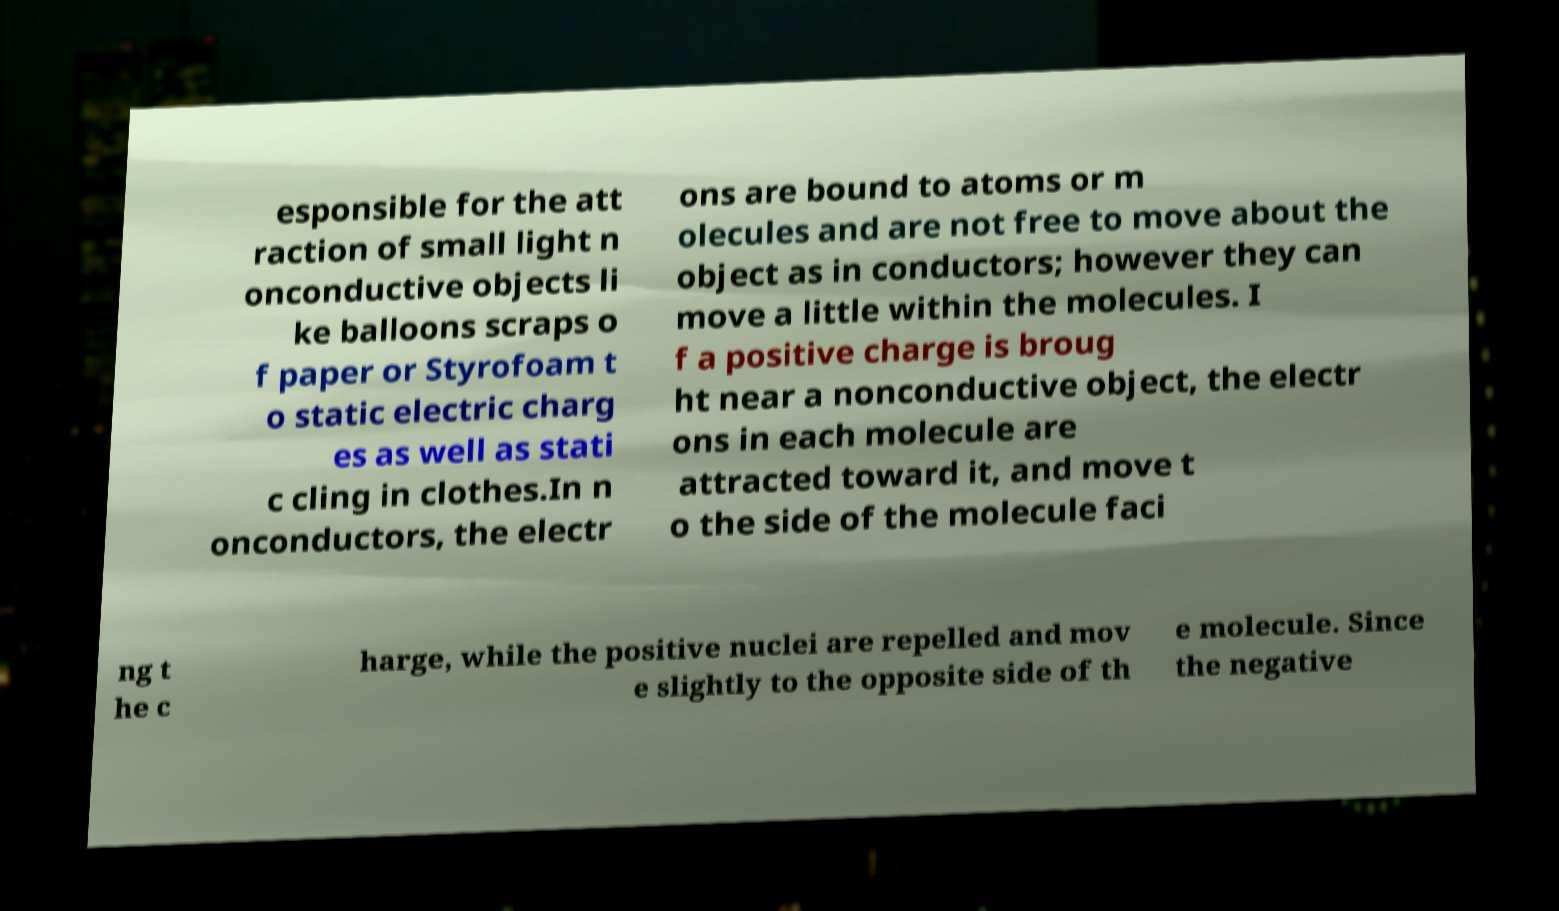Please identify and transcribe the text found in this image. esponsible for the att raction of small light n onconductive objects li ke balloons scraps o f paper or Styrofoam t o static electric charg es as well as stati c cling in clothes.In n onconductors, the electr ons are bound to atoms or m olecules and are not free to move about the object as in conductors; however they can move a little within the molecules. I f a positive charge is broug ht near a nonconductive object, the electr ons in each molecule are attracted toward it, and move t o the side of the molecule faci ng t he c harge, while the positive nuclei are repelled and mov e slightly to the opposite side of th e molecule. Since the negative 